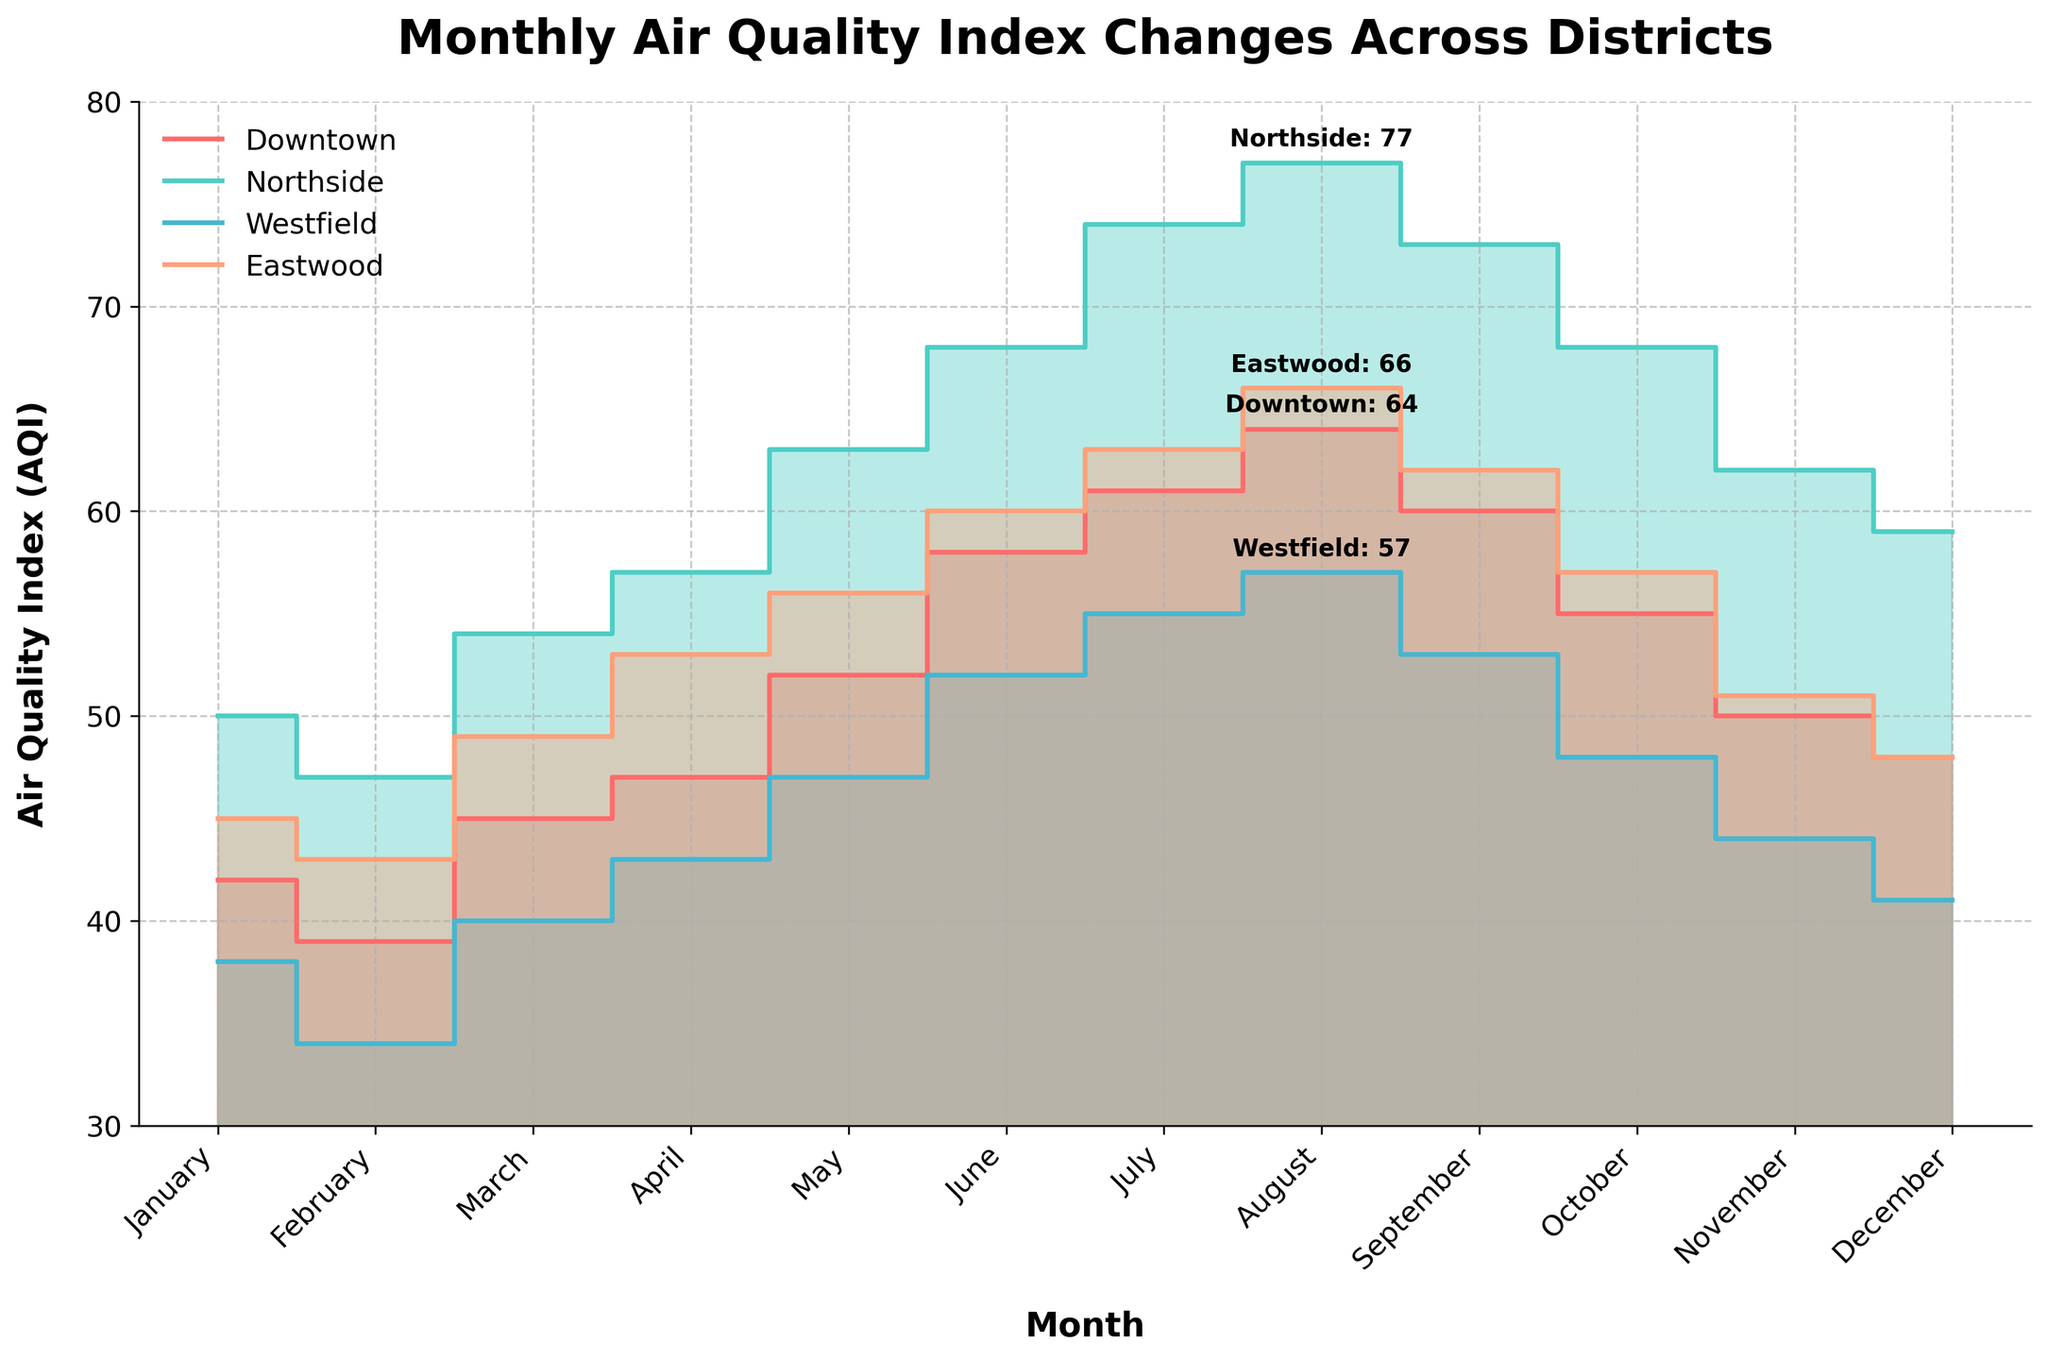What is the highest AQI value for Northside? To find the highest AQI for Northside, locate the line representing Northside and find the peak point on this line. The annotation on the plot marks it as 77.
Answer: 77 Which district has the lowest AQI in January? Check the AQI values for each district in January: Downtown (42), Northside (50), Westfield (38), Eastwood (45). Westfield has the lowest value of 38.
Answer: Westfield What is the average AQI for Downtown over the year? Sum all monthly AQI values for Downtown: 42 + 39 + 45 + 47 + 52 + 58 + 61 + 64 + 60 + 55 + 50 + 48 = 621. Divide by 12 (the number of months) to get the average: 621/12 = 51.75.
Answer: 51.75 How much does the AQI increase from February to March for each district? Calculate the difference between March and February AQI for each district.
- Downtown: 45 - 39 = 6
- Northside: 54 - 47 = 7
- Westfield: 40 - 34 = 6
- Eastwood: 49 - 43 = 6
Answer: Downtown: 6, Northside: 7, Westfield: 6, Eastwood: 6 In which month does Eastwood experience the highest increase in AQI compared to the previous month? Find the largest month-to-month increase for Eastwood by evaluating each difference: 
- February to March (49-43)=6
- March to April (53-49)=4
- April to May (56-53)=3
- May to June (60-56)=4
- June to July (63-60)=3
- July to August (66-63)=3
- August to September (62-66)=-4 (decrease)
- September to October (57-62)=-5 (decrease)
- October to November (51-57)=-6 (decrease)
- November to December (48-51)=-3 (decrease)
The highest increase is from February to March, which is 6.
Answer: February to March Which district shows the steepest decline in AQI from August to September? Review the AQI values from August to September for each district and calculate the drops:
- Downtown: 64 - 60 = 4
- Northside: 77 - 73 = 4
- Westfield: 57 - 53 = 4
- Eastwood: 66 - 62 = 4
All districts experience a decline of 4, so all have the same steepest decline.
Answer: All districts Compare the AQI trends of Downtown and Eastwood from June to August. From June to August: 
- Downtown: June (58) to July (61) to August (64). Increase of 3 from June to July (61-58) and 3 from July to August (64-61).
- Eastwood: June (60) to July (63) to August (66). Increase of 3 from June to July (63-60) and 3 from July to August (66-63).
Both districts have similar trends with increments of 3 each month.
Answer: Similar trends (both increase by 3 each month) Which district has the most stable AQI throughout the year? To determine which district has the most stable AQI, observe fluctuations throughout the year.
- Downtown has monthly changes but varies between 39 and 64.
- Northside has changes within 47 to 77.
- Westfield fluctuates between 34 and 57.
- Eastwood varies between 43 and 66.
Westfield shows the least variation (34 to 57), making it the most stable.
Answer: Westfield What is the difference between the highest and lowest AQI values for Eastwood? Identify Eastwood's highest AQI value (66 in August) and lowest AQI value (43 in February) and calculate the difference: 66 - 43 = 23.
Answer: 23 